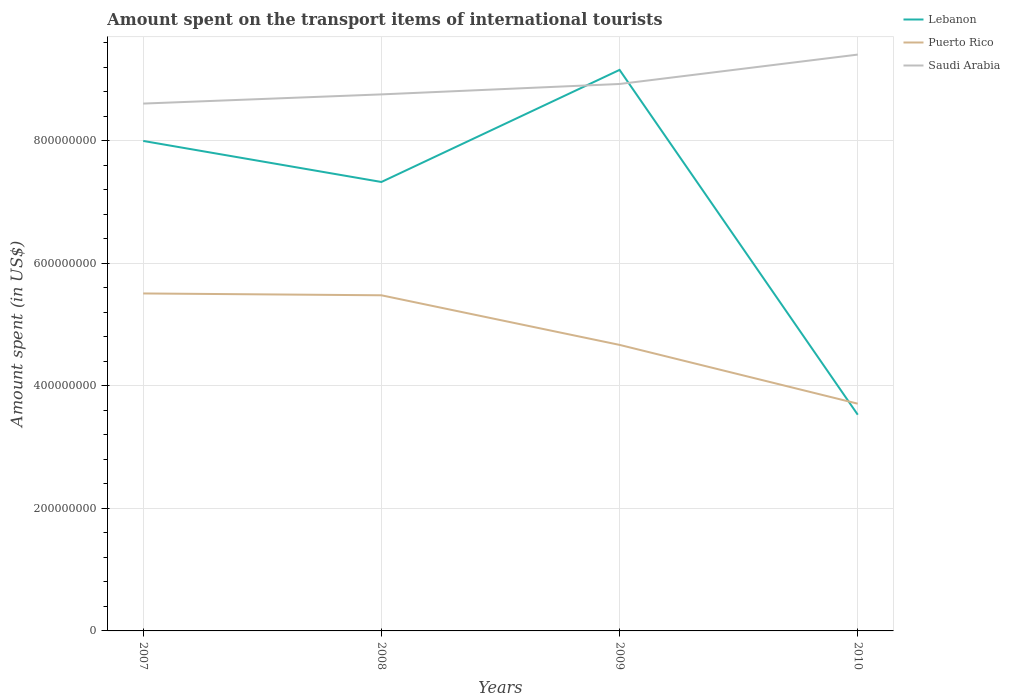Does the line corresponding to Lebanon intersect with the line corresponding to Puerto Rico?
Keep it short and to the point. Yes. Is the number of lines equal to the number of legend labels?
Ensure brevity in your answer.  Yes. Across all years, what is the maximum amount spent on the transport items of international tourists in Saudi Arabia?
Provide a short and direct response. 8.61e+08. What is the total amount spent on the transport items of international tourists in Saudi Arabia in the graph?
Give a very brief answer. -6.50e+07. What is the difference between the highest and the second highest amount spent on the transport items of international tourists in Saudi Arabia?
Your answer should be compact. 8.00e+07. What is the difference between the highest and the lowest amount spent on the transport items of international tourists in Puerto Rico?
Offer a terse response. 2. Is the amount spent on the transport items of international tourists in Puerto Rico strictly greater than the amount spent on the transport items of international tourists in Saudi Arabia over the years?
Make the answer very short. Yes. How many lines are there?
Your answer should be compact. 3. How many years are there in the graph?
Your answer should be very brief. 4. What is the difference between two consecutive major ticks on the Y-axis?
Ensure brevity in your answer.  2.00e+08. Are the values on the major ticks of Y-axis written in scientific E-notation?
Give a very brief answer. No. Does the graph contain any zero values?
Your answer should be very brief. No. Does the graph contain grids?
Give a very brief answer. Yes. Where does the legend appear in the graph?
Make the answer very short. Top right. What is the title of the graph?
Make the answer very short. Amount spent on the transport items of international tourists. What is the label or title of the Y-axis?
Make the answer very short. Amount spent (in US$). What is the Amount spent (in US$) of Lebanon in 2007?
Your response must be concise. 8.00e+08. What is the Amount spent (in US$) of Puerto Rico in 2007?
Provide a short and direct response. 5.51e+08. What is the Amount spent (in US$) of Saudi Arabia in 2007?
Your response must be concise. 8.61e+08. What is the Amount spent (in US$) in Lebanon in 2008?
Your answer should be compact. 7.33e+08. What is the Amount spent (in US$) of Puerto Rico in 2008?
Provide a short and direct response. 5.48e+08. What is the Amount spent (in US$) in Saudi Arabia in 2008?
Make the answer very short. 8.76e+08. What is the Amount spent (in US$) in Lebanon in 2009?
Keep it short and to the point. 9.16e+08. What is the Amount spent (in US$) in Puerto Rico in 2009?
Your response must be concise. 4.67e+08. What is the Amount spent (in US$) in Saudi Arabia in 2009?
Provide a succinct answer. 8.93e+08. What is the Amount spent (in US$) in Lebanon in 2010?
Your answer should be very brief. 3.53e+08. What is the Amount spent (in US$) of Puerto Rico in 2010?
Give a very brief answer. 3.71e+08. What is the Amount spent (in US$) in Saudi Arabia in 2010?
Offer a very short reply. 9.41e+08. Across all years, what is the maximum Amount spent (in US$) in Lebanon?
Your answer should be compact. 9.16e+08. Across all years, what is the maximum Amount spent (in US$) of Puerto Rico?
Provide a short and direct response. 5.51e+08. Across all years, what is the maximum Amount spent (in US$) in Saudi Arabia?
Keep it short and to the point. 9.41e+08. Across all years, what is the minimum Amount spent (in US$) of Lebanon?
Provide a succinct answer. 3.53e+08. Across all years, what is the minimum Amount spent (in US$) in Puerto Rico?
Provide a short and direct response. 3.71e+08. Across all years, what is the minimum Amount spent (in US$) in Saudi Arabia?
Make the answer very short. 8.61e+08. What is the total Amount spent (in US$) of Lebanon in the graph?
Your answer should be compact. 2.80e+09. What is the total Amount spent (in US$) in Puerto Rico in the graph?
Give a very brief answer. 1.94e+09. What is the total Amount spent (in US$) of Saudi Arabia in the graph?
Offer a very short reply. 3.57e+09. What is the difference between the Amount spent (in US$) in Lebanon in 2007 and that in 2008?
Your response must be concise. 6.70e+07. What is the difference between the Amount spent (in US$) of Saudi Arabia in 2007 and that in 2008?
Your answer should be very brief. -1.50e+07. What is the difference between the Amount spent (in US$) in Lebanon in 2007 and that in 2009?
Provide a short and direct response. -1.16e+08. What is the difference between the Amount spent (in US$) of Puerto Rico in 2007 and that in 2009?
Make the answer very short. 8.40e+07. What is the difference between the Amount spent (in US$) of Saudi Arabia in 2007 and that in 2009?
Give a very brief answer. -3.20e+07. What is the difference between the Amount spent (in US$) of Lebanon in 2007 and that in 2010?
Offer a terse response. 4.47e+08. What is the difference between the Amount spent (in US$) in Puerto Rico in 2007 and that in 2010?
Provide a short and direct response. 1.80e+08. What is the difference between the Amount spent (in US$) of Saudi Arabia in 2007 and that in 2010?
Ensure brevity in your answer.  -8.00e+07. What is the difference between the Amount spent (in US$) in Lebanon in 2008 and that in 2009?
Make the answer very short. -1.83e+08. What is the difference between the Amount spent (in US$) in Puerto Rico in 2008 and that in 2009?
Your answer should be very brief. 8.10e+07. What is the difference between the Amount spent (in US$) in Saudi Arabia in 2008 and that in 2009?
Ensure brevity in your answer.  -1.70e+07. What is the difference between the Amount spent (in US$) in Lebanon in 2008 and that in 2010?
Your response must be concise. 3.80e+08. What is the difference between the Amount spent (in US$) in Puerto Rico in 2008 and that in 2010?
Your answer should be very brief. 1.77e+08. What is the difference between the Amount spent (in US$) of Saudi Arabia in 2008 and that in 2010?
Your response must be concise. -6.50e+07. What is the difference between the Amount spent (in US$) of Lebanon in 2009 and that in 2010?
Ensure brevity in your answer.  5.63e+08. What is the difference between the Amount spent (in US$) in Puerto Rico in 2009 and that in 2010?
Make the answer very short. 9.60e+07. What is the difference between the Amount spent (in US$) of Saudi Arabia in 2009 and that in 2010?
Your answer should be very brief. -4.80e+07. What is the difference between the Amount spent (in US$) in Lebanon in 2007 and the Amount spent (in US$) in Puerto Rico in 2008?
Make the answer very short. 2.52e+08. What is the difference between the Amount spent (in US$) of Lebanon in 2007 and the Amount spent (in US$) of Saudi Arabia in 2008?
Make the answer very short. -7.60e+07. What is the difference between the Amount spent (in US$) in Puerto Rico in 2007 and the Amount spent (in US$) in Saudi Arabia in 2008?
Offer a very short reply. -3.25e+08. What is the difference between the Amount spent (in US$) of Lebanon in 2007 and the Amount spent (in US$) of Puerto Rico in 2009?
Ensure brevity in your answer.  3.33e+08. What is the difference between the Amount spent (in US$) in Lebanon in 2007 and the Amount spent (in US$) in Saudi Arabia in 2009?
Provide a short and direct response. -9.30e+07. What is the difference between the Amount spent (in US$) in Puerto Rico in 2007 and the Amount spent (in US$) in Saudi Arabia in 2009?
Provide a succinct answer. -3.42e+08. What is the difference between the Amount spent (in US$) in Lebanon in 2007 and the Amount spent (in US$) in Puerto Rico in 2010?
Make the answer very short. 4.29e+08. What is the difference between the Amount spent (in US$) of Lebanon in 2007 and the Amount spent (in US$) of Saudi Arabia in 2010?
Keep it short and to the point. -1.41e+08. What is the difference between the Amount spent (in US$) in Puerto Rico in 2007 and the Amount spent (in US$) in Saudi Arabia in 2010?
Offer a very short reply. -3.90e+08. What is the difference between the Amount spent (in US$) of Lebanon in 2008 and the Amount spent (in US$) of Puerto Rico in 2009?
Your response must be concise. 2.66e+08. What is the difference between the Amount spent (in US$) in Lebanon in 2008 and the Amount spent (in US$) in Saudi Arabia in 2009?
Offer a terse response. -1.60e+08. What is the difference between the Amount spent (in US$) in Puerto Rico in 2008 and the Amount spent (in US$) in Saudi Arabia in 2009?
Provide a succinct answer. -3.45e+08. What is the difference between the Amount spent (in US$) in Lebanon in 2008 and the Amount spent (in US$) in Puerto Rico in 2010?
Give a very brief answer. 3.62e+08. What is the difference between the Amount spent (in US$) in Lebanon in 2008 and the Amount spent (in US$) in Saudi Arabia in 2010?
Provide a short and direct response. -2.08e+08. What is the difference between the Amount spent (in US$) in Puerto Rico in 2008 and the Amount spent (in US$) in Saudi Arabia in 2010?
Provide a succinct answer. -3.93e+08. What is the difference between the Amount spent (in US$) of Lebanon in 2009 and the Amount spent (in US$) of Puerto Rico in 2010?
Offer a terse response. 5.45e+08. What is the difference between the Amount spent (in US$) in Lebanon in 2009 and the Amount spent (in US$) in Saudi Arabia in 2010?
Give a very brief answer. -2.50e+07. What is the difference between the Amount spent (in US$) of Puerto Rico in 2009 and the Amount spent (in US$) of Saudi Arabia in 2010?
Ensure brevity in your answer.  -4.74e+08. What is the average Amount spent (in US$) of Lebanon per year?
Provide a succinct answer. 7.00e+08. What is the average Amount spent (in US$) in Puerto Rico per year?
Offer a terse response. 4.84e+08. What is the average Amount spent (in US$) of Saudi Arabia per year?
Your response must be concise. 8.93e+08. In the year 2007, what is the difference between the Amount spent (in US$) of Lebanon and Amount spent (in US$) of Puerto Rico?
Make the answer very short. 2.49e+08. In the year 2007, what is the difference between the Amount spent (in US$) in Lebanon and Amount spent (in US$) in Saudi Arabia?
Ensure brevity in your answer.  -6.10e+07. In the year 2007, what is the difference between the Amount spent (in US$) of Puerto Rico and Amount spent (in US$) of Saudi Arabia?
Offer a very short reply. -3.10e+08. In the year 2008, what is the difference between the Amount spent (in US$) of Lebanon and Amount spent (in US$) of Puerto Rico?
Your answer should be very brief. 1.85e+08. In the year 2008, what is the difference between the Amount spent (in US$) in Lebanon and Amount spent (in US$) in Saudi Arabia?
Your answer should be very brief. -1.43e+08. In the year 2008, what is the difference between the Amount spent (in US$) in Puerto Rico and Amount spent (in US$) in Saudi Arabia?
Make the answer very short. -3.28e+08. In the year 2009, what is the difference between the Amount spent (in US$) in Lebanon and Amount spent (in US$) in Puerto Rico?
Ensure brevity in your answer.  4.49e+08. In the year 2009, what is the difference between the Amount spent (in US$) in Lebanon and Amount spent (in US$) in Saudi Arabia?
Your answer should be compact. 2.30e+07. In the year 2009, what is the difference between the Amount spent (in US$) of Puerto Rico and Amount spent (in US$) of Saudi Arabia?
Ensure brevity in your answer.  -4.26e+08. In the year 2010, what is the difference between the Amount spent (in US$) in Lebanon and Amount spent (in US$) in Puerto Rico?
Provide a succinct answer. -1.80e+07. In the year 2010, what is the difference between the Amount spent (in US$) of Lebanon and Amount spent (in US$) of Saudi Arabia?
Ensure brevity in your answer.  -5.88e+08. In the year 2010, what is the difference between the Amount spent (in US$) of Puerto Rico and Amount spent (in US$) of Saudi Arabia?
Your response must be concise. -5.70e+08. What is the ratio of the Amount spent (in US$) in Lebanon in 2007 to that in 2008?
Give a very brief answer. 1.09. What is the ratio of the Amount spent (in US$) in Puerto Rico in 2007 to that in 2008?
Your answer should be very brief. 1.01. What is the ratio of the Amount spent (in US$) of Saudi Arabia in 2007 to that in 2008?
Give a very brief answer. 0.98. What is the ratio of the Amount spent (in US$) of Lebanon in 2007 to that in 2009?
Your response must be concise. 0.87. What is the ratio of the Amount spent (in US$) of Puerto Rico in 2007 to that in 2009?
Your response must be concise. 1.18. What is the ratio of the Amount spent (in US$) in Saudi Arabia in 2007 to that in 2009?
Your response must be concise. 0.96. What is the ratio of the Amount spent (in US$) in Lebanon in 2007 to that in 2010?
Make the answer very short. 2.27. What is the ratio of the Amount spent (in US$) of Puerto Rico in 2007 to that in 2010?
Your answer should be very brief. 1.49. What is the ratio of the Amount spent (in US$) of Saudi Arabia in 2007 to that in 2010?
Your answer should be very brief. 0.92. What is the ratio of the Amount spent (in US$) of Lebanon in 2008 to that in 2009?
Your response must be concise. 0.8. What is the ratio of the Amount spent (in US$) of Puerto Rico in 2008 to that in 2009?
Ensure brevity in your answer.  1.17. What is the ratio of the Amount spent (in US$) of Lebanon in 2008 to that in 2010?
Provide a succinct answer. 2.08. What is the ratio of the Amount spent (in US$) of Puerto Rico in 2008 to that in 2010?
Keep it short and to the point. 1.48. What is the ratio of the Amount spent (in US$) in Saudi Arabia in 2008 to that in 2010?
Make the answer very short. 0.93. What is the ratio of the Amount spent (in US$) in Lebanon in 2009 to that in 2010?
Your answer should be compact. 2.59. What is the ratio of the Amount spent (in US$) in Puerto Rico in 2009 to that in 2010?
Ensure brevity in your answer.  1.26. What is the ratio of the Amount spent (in US$) in Saudi Arabia in 2009 to that in 2010?
Your answer should be compact. 0.95. What is the difference between the highest and the second highest Amount spent (in US$) in Lebanon?
Provide a short and direct response. 1.16e+08. What is the difference between the highest and the second highest Amount spent (in US$) of Saudi Arabia?
Your answer should be compact. 4.80e+07. What is the difference between the highest and the lowest Amount spent (in US$) of Lebanon?
Ensure brevity in your answer.  5.63e+08. What is the difference between the highest and the lowest Amount spent (in US$) of Puerto Rico?
Provide a succinct answer. 1.80e+08. What is the difference between the highest and the lowest Amount spent (in US$) in Saudi Arabia?
Offer a very short reply. 8.00e+07. 